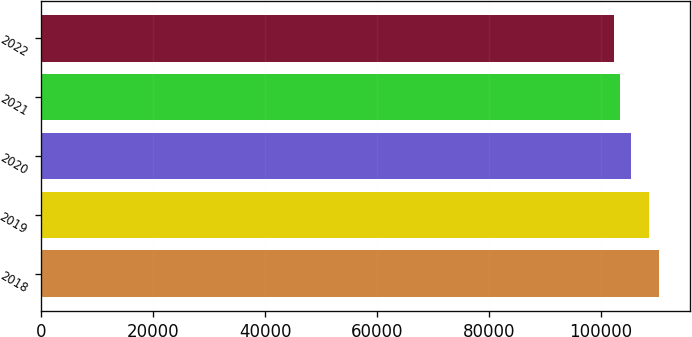<chart> <loc_0><loc_0><loc_500><loc_500><bar_chart><fcel>2018<fcel>2019<fcel>2020<fcel>2021<fcel>2022<nl><fcel>110388<fcel>108604<fcel>105341<fcel>103358<fcel>102335<nl></chart> 